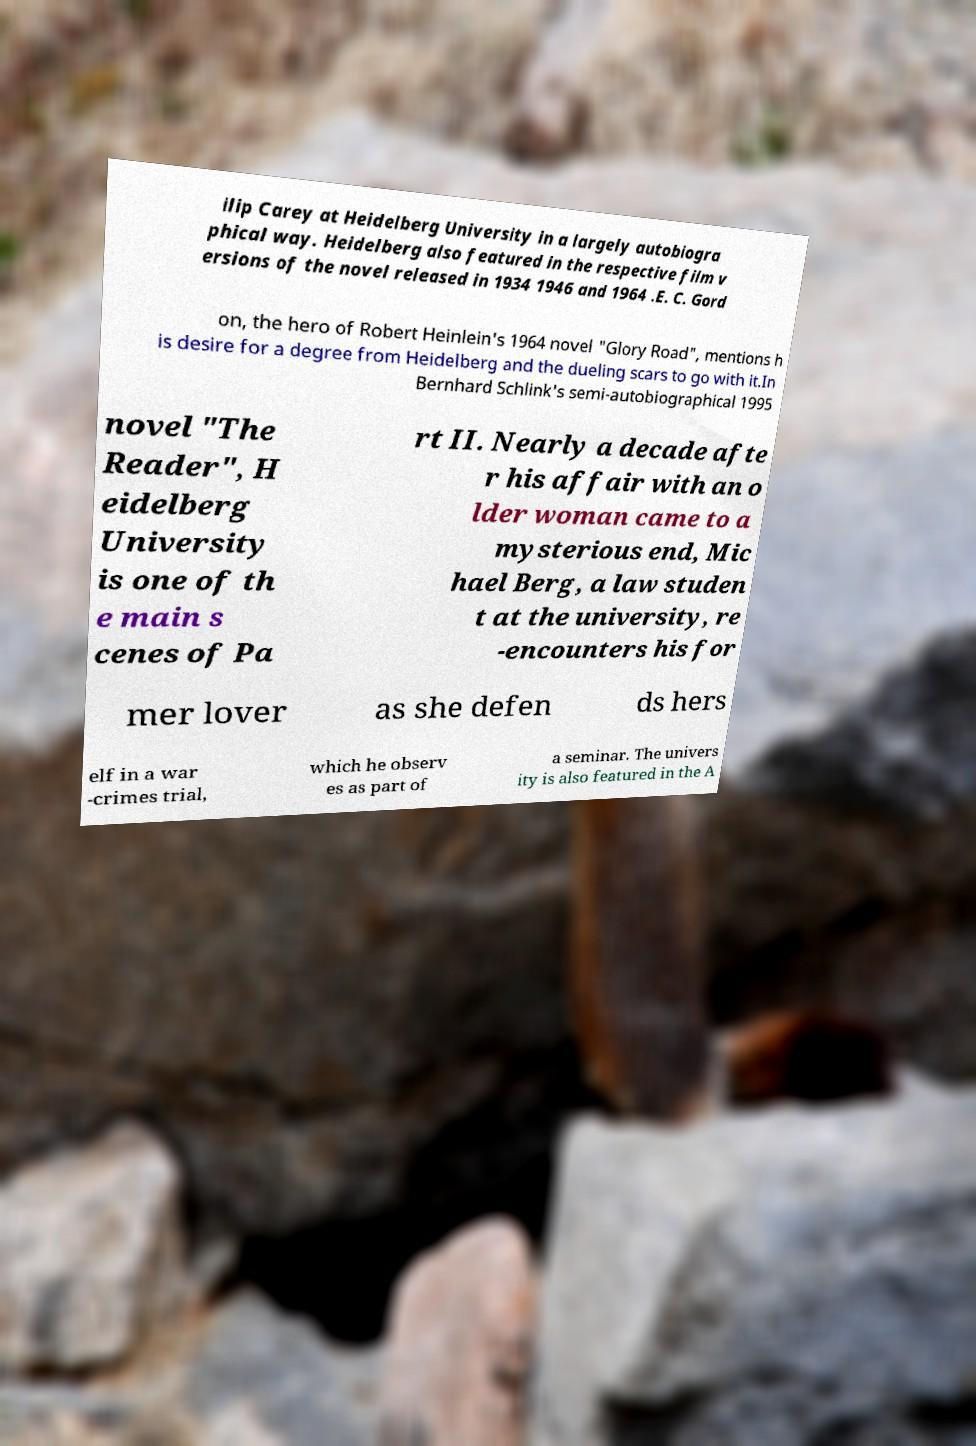Please read and relay the text visible in this image. What does it say? ilip Carey at Heidelberg University in a largely autobiogra phical way. Heidelberg also featured in the respective film v ersions of the novel released in 1934 1946 and 1964 .E. C. Gord on, the hero of Robert Heinlein's 1964 novel "Glory Road", mentions h is desire for a degree from Heidelberg and the dueling scars to go with it.In Bernhard Schlink's semi-autobiographical 1995 novel "The Reader", H eidelberg University is one of th e main s cenes of Pa rt II. Nearly a decade afte r his affair with an o lder woman came to a mysterious end, Mic hael Berg, a law studen t at the university, re -encounters his for mer lover as she defen ds hers elf in a war -crimes trial, which he observ es as part of a seminar. The univers ity is also featured in the A 